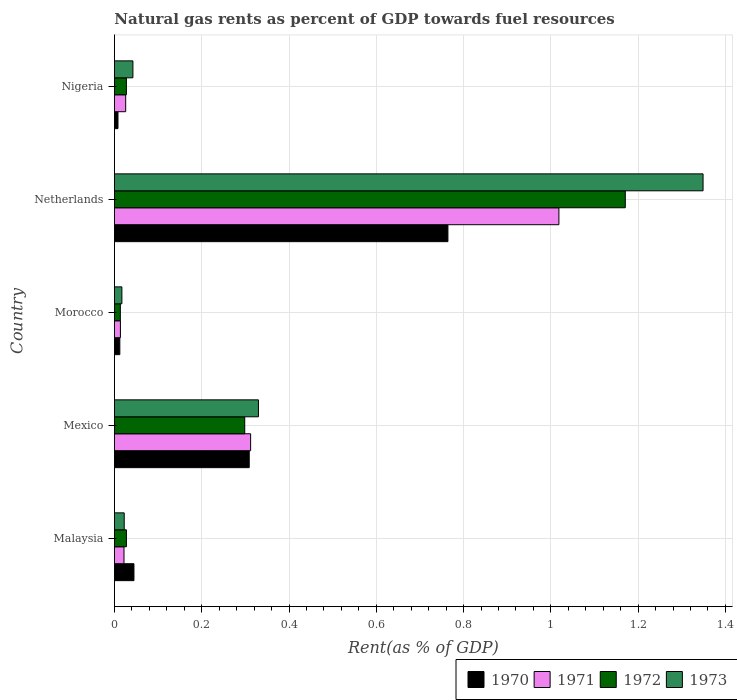How many different coloured bars are there?
Your answer should be very brief. 4. How many groups of bars are there?
Give a very brief answer. 5. Are the number of bars per tick equal to the number of legend labels?
Keep it short and to the point. Yes. Are the number of bars on each tick of the Y-axis equal?
Ensure brevity in your answer.  Yes. What is the matural gas rent in 1971 in Mexico?
Offer a very short reply. 0.31. Across all countries, what is the maximum matural gas rent in 1971?
Make the answer very short. 1.02. Across all countries, what is the minimum matural gas rent in 1972?
Offer a terse response. 0.01. In which country was the matural gas rent in 1973 maximum?
Keep it short and to the point. Netherlands. In which country was the matural gas rent in 1973 minimum?
Your answer should be very brief. Morocco. What is the total matural gas rent in 1970 in the graph?
Ensure brevity in your answer.  1.14. What is the difference between the matural gas rent in 1970 in Malaysia and that in Netherlands?
Keep it short and to the point. -0.72. What is the difference between the matural gas rent in 1970 in Nigeria and the matural gas rent in 1973 in Mexico?
Provide a succinct answer. -0.32. What is the average matural gas rent in 1972 per country?
Your response must be concise. 0.31. What is the difference between the matural gas rent in 1973 and matural gas rent in 1970 in Malaysia?
Offer a very short reply. -0.02. What is the ratio of the matural gas rent in 1973 in Morocco to that in Netherlands?
Make the answer very short. 0.01. What is the difference between the highest and the second highest matural gas rent in 1973?
Give a very brief answer. 1.02. What is the difference between the highest and the lowest matural gas rent in 1971?
Provide a succinct answer. 1. Is it the case that in every country, the sum of the matural gas rent in 1971 and matural gas rent in 1972 is greater than the sum of matural gas rent in 1973 and matural gas rent in 1970?
Offer a terse response. No. What does the 2nd bar from the top in Morocco represents?
Provide a succinct answer. 1972. How many bars are there?
Provide a short and direct response. 20. How many legend labels are there?
Provide a succinct answer. 4. What is the title of the graph?
Offer a very short reply. Natural gas rents as percent of GDP towards fuel resources. What is the label or title of the X-axis?
Provide a short and direct response. Rent(as % of GDP). What is the Rent(as % of GDP) of 1970 in Malaysia?
Your response must be concise. 0.04. What is the Rent(as % of GDP) in 1971 in Malaysia?
Offer a very short reply. 0.02. What is the Rent(as % of GDP) in 1972 in Malaysia?
Offer a very short reply. 0.03. What is the Rent(as % of GDP) in 1973 in Malaysia?
Your answer should be very brief. 0.02. What is the Rent(as % of GDP) of 1970 in Mexico?
Offer a terse response. 0.31. What is the Rent(as % of GDP) in 1971 in Mexico?
Keep it short and to the point. 0.31. What is the Rent(as % of GDP) in 1972 in Mexico?
Give a very brief answer. 0.3. What is the Rent(as % of GDP) in 1973 in Mexico?
Your answer should be compact. 0.33. What is the Rent(as % of GDP) in 1970 in Morocco?
Offer a terse response. 0.01. What is the Rent(as % of GDP) in 1971 in Morocco?
Provide a short and direct response. 0.01. What is the Rent(as % of GDP) in 1972 in Morocco?
Make the answer very short. 0.01. What is the Rent(as % of GDP) in 1973 in Morocco?
Give a very brief answer. 0.02. What is the Rent(as % of GDP) of 1970 in Netherlands?
Ensure brevity in your answer.  0.76. What is the Rent(as % of GDP) in 1971 in Netherlands?
Offer a very short reply. 1.02. What is the Rent(as % of GDP) of 1972 in Netherlands?
Make the answer very short. 1.17. What is the Rent(as % of GDP) in 1973 in Netherlands?
Offer a terse response. 1.35. What is the Rent(as % of GDP) in 1970 in Nigeria?
Your response must be concise. 0.01. What is the Rent(as % of GDP) of 1971 in Nigeria?
Your response must be concise. 0.03. What is the Rent(as % of GDP) of 1972 in Nigeria?
Give a very brief answer. 0.03. What is the Rent(as % of GDP) of 1973 in Nigeria?
Give a very brief answer. 0.04. Across all countries, what is the maximum Rent(as % of GDP) of 1970?
Provide a succinct answer. 0.76. Across all countries, what is the maximum Rent(as % of GDP) of 1971?
Provide a short and direct response. 1.02. Across all countries, what is the maximum Rent(as % of GDP) in 1972?
Your answer should be very brief. 1.17. Across all countries, what is the maximum Rent(as % of GDP) of 1973?
Offer a terse response. 1.35. Across all countries, what is the minimum Rent(as % of GDP) in 1970?
Your response must be concise. 0.01. Across all countries, what is the minimum Rent(as % of GDP) of 1971?
Your answer should be compact. 0.01. Across all countries, what is the minimum Rent(as % of GDP) of 1972?
Your answer should be compact. 0.01. Across all countries, what is the minimum Rent(as % of GDP) of 1973?
Give a very brief answer. 0.02. What is the total Rent(as % of GDP) of 1970 in the graph?
Provide a succinct answer. 1.14. What is the total Rent(as % of GDP) of 1971 in the graph?
Your answer should be very brief. 1.39. What is the total Rent(as % of GDP) of 1972 in the graph?
Give a very brief answer. 1.54. What is the total Rent(as % of GDP) in 1973 in the graph?
Offer a terse response. 1.76. What is the difference between the Rent(as % of GDP) in 1970 in Malaysia and that in Mexico?
Make the answer very short. -0.26. What is the difference between the Rent(as % of GDP) of 1971 in Malaysia and that in Mexico?
Provide a short and direct response. -0.29. What is the difference between the Rent(as % of GDP) in 1972 in Malaysia and that in Mexico?
Your answer should be compact. -0.27. What is the difference between the Rent(as % of GDP) of 1973 in Malaysia and that in Mexico?
Provide a succinct answer. -0.31. What is the difference between the Rent(as % of GDP) of 1970 in Malaysia and that in Morocco?
Your answer should be very brief. 0.03. What is the difference between the Rent(as % of GDP) of 1971 in Malaysia and that in Morocco?
Your answer should be compact. 0.01. What is the difference between the Rent(as % of GDP) of 1972 in Malaysia and that in Morocco?
Your answer should be compact. 0.01. What is the difference between the Rent(as % of GDP) in 1973 in Malaysia and that in Morocco?
Offer a terse response. 0.01. What is the difference between the Rent(as % of GDP) in 1970 in Malaysia and that in Netherlands?
Keep it short and to the point. -0.72. What is the difference between the Rent(as % of GDP) of 1971 in Malaysia and that in Netherlands?
Your answer should be very brief. -1. What is the difference between the Rent(as % of GDP) of 1972 in Malaysia and that in Netherlands?
Give a very brief answer. -1.14. What is the difference between the Rent(as % of GDP) of 1973 in Malaysia and that in Netherlands?
Offer a very short reply. -1.33. What is the difference between the Rent(as % of GDP) of 1970 in Malaysia and that in Nigeria?
Offer a terse response. 0.04. What is the difference between the Rent(as % of GDP) of 1971 in Malaysia and that in Nigeria?
Ensure brevity in your answer.  -0. What is the difference between the Rent(as % of GDP) in 1973 in Malaysia and that in Nigeria?
Provide a succinct answer. -0.02. What is the difference between the Rent(as % of GDP) in 1970 in Mexico and that in Morocco?
Ensure brevity in your answer.  0.3. What is the difference between the Rent(as % of GDP) of 1971 in Mexico and that in Morocco?
Offer a very short reply. 0.3. What is the difference between the Rent(as % of GDP) in 1972 in Mexico and that in Morocco?
Your answer should be compact. 0.28. What is the difference between the Rent(as % of GDP) of 1973 in Mexico and that in Morocco?
Your answer should be very brief. 0.31. What is the difference between the Rent(as % of GDP) in 1970 in Mexico and that in Netherlands?
Offer a very short reply. -0.46. What is the difference between the Rent(as % of GDP) of 1971 in Mexico and that in Netherlands?
Offer a terse response. -0.71. What is the difference between the Rent(as % of GDP) in 1972 in Mexico and that in Netherlands?
Keep it short and to the point. -0.87. What is the difference between the Rent(as % of GDP) in 1973 in Mexico and that in Netherlands?
Give a very brief answer. -1.02. What is the difference between the Rent(as % of GDP) in 1970 in Mexico and that in Nigeria?
Make the answer very short. 0.3. What is the difference between the Rent(as % of GDP) in 1971 in Mexico and that in Nigeria?
Your response must be concise. 0.29. What is the difference between the Rent(as % of GDP) of 1972 in Mexico and that in Nigeria?
Provide a succinct answer. 0.27. What is the difference between the Rent(as % of GDP) in 1973 in Mexico and that in Nigeria?
Your response must be concise. 0.29. What is the difference between the Rent(as % of GDP) in 1970 in Morocco and that in Netherlands?
Your response must be concise. -0.75. What is the difference between the Rent(as % of GDP) in 1971 in Morocco and that in Netherlands?
Ensure brevity in your answer.  -1. What is the difference between the Rent(as % of GDP) of 1972 in Morocco and that in Netherlands?
Provide a succinct answer. -1.16. What is the difference between the Rent(as % of GDP) in 1973 in Morocco and that in Netherlands?
Make the answer very short. -1.33. What is the difference between the Rent(as % of GDP) of 1970 in Morocco and that in Nigeria?
Your response must be concise. 0. What is the difference between the Rent(as % of GDP) in 1971 in Morocco and that in Nigeria?
Make the answer very short. -0.01. What is the difference between the Rent(as % of GDP) in 1972 in Morocco and that in Nigeria?
Provide a short and direct response. -0.01. What is the difference between the Rent(as % of GDP) of 1973 in Morocco and that in Nigeria?
Your response must be concise. -0.03. What is the difference between the Rent(as % of GDP) in 1970 in Netherlands and that in Nigeria?
Keep it short and to the point. 0.76. What is the difference between the Rent(as % of GDP) in 1971 in Netherlands and that in Nigeria?
Ensure brevity in your answer.  0.99. What is the difference between the Rent(as % of GDP) in 1972 in Netherlands and that in Nigeria?
Your answer should be very brief. 1.14. What is the difference between the Rent(as % of GDP) in 1973 in Netherlands and that in Nigeria?
Give a very brief answer. 1.31. What is the difference between the Rent(as % of GDP) in 1970 in Malaysia and the Rent(as % of GDP) in 1971 in Mexico?
Your answer should be very brief. -0.27. What is the difference between the Rent(as % of GDP) of 1970 in Malaysia and the Rent(as % of GDP) of 1972 in Mexico?
Provide a succinct answer. -0.25. What is the difference between the Rent(as % of GDP) of 1970 in Malaysia and the Rent(as % of GDP) of 1973 in Mexico?
Ensure brevity in your answer.  -0.29. What is the difference between the Rent(as % of GDP) of 1971 in Malaysia and the Rent(as % of GDP) of 1972 in Mexico?
Provide a short and direct response. -0.28. What is the difference between the Rent(as % of GDP) in 1971 in Malaysia and the Rent(as % of GDP) in 1973 in Mexico?
Your answer should be very brief. -0.31. What is the difference between the Rent(as % of GDP) of 1972 in Malaysia and the Rent(as % of GDP) of 1973 in Mexico?
Provide a short and direct response. -0.3. What is the difference between the Rent(as % of GDP) of 1970 in Malaysia and the Rent(as % of GDP) of 1971 in Morocco?
Your answer should be very brief. 0.03. What is the difference between the Rent(as % of GDP) in 1970 in Malaysia and the Rent(as % of GDP) in 1972 in Morocco?
Offer a terse response. 0.03. What is the difference between the Rent(as % of GDP) in 1970 in Malaysia and the Rent(as % of GDP) in 1973 in Morocco?
Make the answer very short. 0.03. What is the difference between the Rent(as % of GDP) in 1971 in Malaysia and the Rent(as % of GDP) in 1972 in Morocco?
Your response must be concise. 0.01. What is the difference between the Rent(as % of GDP) of 1971 in Malaysia and the Rent(as % of GDP) of 1973 in Morocco?
Ensure brevity in your answer.  0. What is the difference between the Rent(as % of GDP) of 1972 in Malaysia and the Rent(as % of GDP) of 1973 in Morocco?
Provide a succinct answer. 0.01. What is the difference between the Rent(as % of GDP) in 1970 in Malaysia and the Rent(as % of GDP) in 1971 in Netherlands?
Provide a succinct answer. -0.97. What is the difference between the Rent(as % of GDP) in 1970 in Malaysia and the Rent(as % of GDP) in 1972 in Netherlands?
Provide a succinct answer. -1.13. What is the difference between the Rent(as % of GDP) of 1970 in Malaysia and the Rent(as % of GDP) of 1973 in Netherlands?
Ensure brevity in your answer.  -1.3. What is the difference between the Rent(as % of GDP) of 1971 in Malaysia and the Rent(as % of GDP) of 1972 in Netherlands?
Your response must be concise. -1.15. What is the difference between the Rent(as % of GDP) of 1971 in Malaysia and the Rent(as % of GDP) of 1973 in Netherlands?
Provide a succinct answer. -1.33. What is the difference between the Rent(as % of GDP) of 1972 in Malaysia and the Rent(as % of GDP) of 1973 in Netherlands?
Keep it short and to the point. -1.32. What is the difference between the Rent(as % of GDP) of 1970 in Malaysia and the Rent(as % of GDP) of 1971 in Nigeria?
Offer a terse response. 0.02. What is the difference between the Rent(as % of GDP) of 1970 in Malaysia and the Rent(as % of GDP) of 1972 in Nigeria?
Your answer should be compact. 0.02. What is the difference between the Rent(as % of GDP) of 1970 in Malaysia and the Rent(as % of GDP) of 1973 in Nigeria?
Provide a succinct answer. 0. What is the difference between the Rent(as % of GDP) in 1971 in Malaysia and the Rent(as % of GDP) in 1972 in Nigeria?
Keep it short and to the point. -0.01. What is the difference between the Rent(as % of GDP) of 1971 in Malaysia and the Rent(as % of GDP) of 1973 in Nigeria?
Make the answer very short. -0.02. What is the difference between the Rent(as % of GDP) of 1972 in Malaysia and the Rent(as % of GDP) of 1973 in Nigeria?
Offer a very short reply. -0.01. What is the difference between the Rent(as % of GDP) of 1970 in Mexico and the Rent(as % of GDP) of 1971 in Morocco?
Your answer should be compact. 0.3. What is the difference between the Rent(as % of GDP) in 1970 in Mexico and the Rent(as % of GDP) in 1972 in Morocco?
Provide a succinct answer. 0.3. What is the difference between the Rent(as % of GDP) in 1970 in Mexico and the Rent(as % of GDP) in 1973 in Morocco?
Your answer should be compact. 0.29. What is the difference between the Rent(as % of GDP) of 1971 in Mexico and the Rent(as % of GDP) of 1972 in Morocco?
Make the answer very short. 0.3. What is the difference between the Rent(as % of GDP) in 1971 in Mexico and the Rent(as % of GDP) in 1973 in Morocco?
Provide a succinct answer. 0.29. What is the difference between the Rent(as % of GDP) in 1972 in Mexico and the Rent(as % of GDP) in 1973 in Morocco?
Provide a short and direct response. 0.28. What is the difference between the Rent(as % of GDP) of 1970 in Mexico and the Rent(as % of GDP) of 1971 in Netherlands?
Provide a succinct answer. -0.71. What is the difference between the Rent(as % of GDP) of 1970 in Mexico and the Rent(as % of GDP) of 1972 in Netherlands?
Keep it short and to the point. -0.86. What is the difference between the Rent(as % of GDP) of 1970 in Mexico and the Rent(as % of GDP) of 1973 in Netherlands?
Your response must be concise. -1.04. What is the difference between the Rent(as % of GDP) in 1971 in Mexico and the Rent(as % of GDP) in 1972 in Netherlands?
Offer a very short reply. -0.86. What is the difference between the Rent(as % of GDP) in 1971 in Mexico and the Rent(as % of GDP) in 1973 in Netherlands?
Offer a very short reply. -1.04. What is the difference between the Rent(as % of GDP) in 1972 in Mexico and the Rent(as % of GDP) in 1973 in Netherlands?
Give a very brief answer. -1.05. What is the difference between the Rent(as % of GDP) in 1970 in Mexico and the Rent(as % of GDP) in 1971 in Nigeria?
Offer a very short reply. 0.28. What is the difference between the Rent(as % of GDP) of 1970 in Mexico and the Rent(as % of GDP) of 1972 in Nigeria?
Ensure brevity in your answer.  0.28. What is the difference between the Rent(as % of GDP) of 1970 in Mexico and the Rent(as % of GDP) of 1973 in Nigeria?
Offer a very short reply. 0.27. What is the difference between the Rent(as % of GDP) of 1971 in Mexico and the Rent(as % of GDP) of 1972 in Nigeria?
Give a very brief answer. 0.28. What is the difference between the Rent(as % of GDP) of 1971 in Mexico and the Rent(as % of GDP) of 1973 in Nigeria?
Offer a very short reply. 0.27. What is the difference between the Rent(as % of GDP) of 1972 in Mexico and the Rent(as % of GDP) of 1973 in Nigeria?
Offer a terse response. 0.26. What is the difference between the Rent(as % of GDP) of 1970 in Morocco and the Rent(as % of GDP) of 1971 in Netherlands?
Provide a short and direct response. -1.01. What is the difference between the Rent(as % of GDP) of 1970 in Morocco and the Rent(as % of GDP) of 1972 in Netherlands?
Provide a succinct answer. -1.16. What is the difference between the Rent(as % of GDP) in 1970 in Morocco and the Rent(as % of GDP) in 1973 in Netherlands?
Your answer should be compact. -1.34. What is the difference between the Rent(as % of GDP) of 1971 in Morocco and the Rent(as % of GDP) of 1972 in Netherlands?
Your response must be concise. -1.16. What is the difference between the Rent(as % of GDP) in 1971 in Morocco and the Rent(as % of GDP) in 1973 in Netherlands?
Your answer should be very brief. -1.33. What is the difference between the Rent(as % of GDP) in 1972 in Morocco and the Rent(as % of GDP) in 1973 in Netherlands?
Your answer should be compact. -1.34. What is the difference between the Rent(as % of GDP) in 1970 in Morocco and the Rent(as % of GDP) in 1971 in Nigeria?
Your response must be concise. -0.01. What is the difference between the Rent(as % of GDP) of 1970 in Morocco and the Rent(as % of GDP) of 1972 in Nigeria?
Provide a succinct answer. -0.02. What is the difference between the Rent(as % of GDP) in 1970 in Morocco and the Rent(as % of GDP) in 1973 in Nigeria?
Give a very brief answer. -0.03. What is the difference between the Rent(as % of GDP) in 1971 in Morocco and the Rent(as % of GDP) in 1972 in Nigeria?
Give a very brief answer. -0.01. What is the difference between the Rent(as % of GDP) in 1971 in Morocco and the Rent(as % of GDP) in 1973 in Nigeria?
Your answer should be compact. -0.03. What is the difference between the Rent(as % of GDP) of 1972 in Morocco and the Rent(as % of GDP) of 1973 in Nigeria?
Keep it short and to the point. -0.03. What is the difference between the Rent(as % of GDP) of 1970 in Netherlands and the Rent(as % of GDP) of 1971 in Nigeria?
Give a very brief answer. 0.74. What is the difference between the Rent(as % of GDP) in 1970 in Netherlands and the Rent(as % of GDP) in 1972 in Nigeria?
Your answer should be compact. 0.74. What is the difference between the Rent(as % of GDP) in 1970 in Netherlands and the Rent(as % of GDP) in 1973 in Nigeria?
Give a very brief answer. 0.72. What is the difference between the Rent(as % of GDP) in 1971 in Netherlands and the Rent(as % of GDP) in 1972 in Nigeria?
Provide a short and direct response. 0.99. What is the difference between the Rent(as % of GDP) of 1972 in Netherlands and the Rent(as % of GDP) of 1973 in Nigeria?
Make the answer very short. 1.13. What is the average Rent(as % of GDP) in 1970 per country?
Your answer should be compact. 0.23. What is the average Rent(as % of GDP) of 1971 per country?
Offer a terse response. 0.28. What is the average Rent(as % of GDP) of 1972 per country?
Ensure brevity in your answer.  0.31. What is the average Rent(as % of GDP) of 1973 per country?
Your answer should be very brief. 0.35. What is the difference between the Rent(as % of GDP) of 1970 and Rent(as % of GDP) of 1971 in Malaysia?
Provide a succinct answer. 0.02. What is the difference between the Rent(as % of GDP) of 1970 and Rent(as % of GDP) of 1972 in Malaysia?
Make the answer very short. 0.02. What is the difference between the Rent(as % of GDP) of 1970 and Rent(as % of GDP) of 1973 in Malaysia?
Make the answer very short. 0.02. What is the difference between the Rent(as % of GDP) in 1971 and Rent(as % of GDP) in 1972 in Malaysia?
Your answer should be very brief. -0.01. What is the difference between the Rent(as % of GDP) of 1971 and Rent(as % of GDP) of 1973 in Malaysia?
Offer a very short reply. -0. What is the difference between the Rent(as % of GDP) in 1972 and Rent(as % of GDP) in 1973 in Malaysia?
Provide a succinct answer. 0.01. What is the difference between the Rent(as % of GDP) in 1970 and Rent(as % of GDP) in 1971 in Mexico?
Give a very brief answer. -0. What is the difference between the Rent(as % of GDP) of 1970 and Rent(as % of GDP) of 1972 in Mexico?
Make the answer very short. 0.01. What is the difference between the Rent(as % of GDP) in 1970 and Rent(as % of GDP) in 1973 in Mexico?
Your answer should be very brief. -0.02. What is the difference between the Rent(as % of GDP) in 1971 and Rent(as % of GDP) in 1972 in Mexico?
Your answer should be very brief. 0.01. What is the difference between the Rent(as % of GDP) of 1971 and Rent(as % of GDP) of 1973 in Mexico?
Give a very brief answer. -0.02. What is the difference between the Rent(as % of GDP) in 1972 and Rent(as % of GDP) in 1973 in Mexico?
Your response must be concise. -0.03. What is the difference between the Rent(as % of GDP) of 1970 and Rent(as % of GDP) of 1971 in Morocco?
Provide a short and direct response. -0. What is the difference between the Rent(as % of GDP) in 1970 and Rent(as % of GDP) in 1972 in Morocco?
Provide a short and direct response. -0. What is the difference between the Rent(as % of GDP) of 1970 and Rent(as % of GDP) of 1973 in Morocco?
Offer a very short reply. -0. What is the difference between the Rent(as % of GDP) in 1971 and Rent(as % of GDP) in 1972 in Morocco?
Make the answer very short. 0. What is the difference between the Rent(as % of GDP) of 1971 and Rent(as % of GDP) of 1973 in Morocco?
Offer a very short reply. -0. What is the difference between the Rent(as % of GDP) in 1972 and Rent(as % of GDP) in 1973 in Morocco?
Provide a succinct answer. -0. What is the difference between the Rent(as % of GDP) in 1970 and Rent(as % of GDP) in 1971 in Netherlands?
Provide a succinct answer. -0.25. What is the difference between the Rent(as % of GDP) in 1970 and Rent(as % of GDP) in 1972 in Netherlands?
Provide a short and direct response. -0.41. What is the difference between the Rent(as % of GDP) in 1970 and Rent(as % of GDP) in 1973 in Netherlands?
Keep it short and to the point. -0.58. What is the difference between the Rent(as % of GDP) of 1971 and Rent(as % of GDP) of 1972 in Netherlands?
Your answer should be compact. -0.15. What is the difference between the Rent(as % of GDP) of 1971 and Rent(as % of GDP) of 1973 in Netherlands?
Keep it short and to the point. -0.33. What is the difference between the Rent(as % of GDP) of 1972 and Rent(as % of GDP) of 1973 in Netherlands?
Make the answer very short. -0.18. What is the difference between the Rent(as % of GDP) in 1970 and Rent(as % of GDP) in 1971 in Nigeria?
Make the answer very short. -0.02. What is the difference between the Rent(as % of GDP) of 1970 and Rent(as % of GDP) of 1972 in Nigeria?
Your answer should be very brief. -0.02. What is the difference between the Rent(as % of GDP) in 1970 and Rent(as % of GDP) in 1973 in Nigeria?
Your answer should be very brief. -0.03. What is the difference between the Rent(as % of GDP) in 1971 and Rent(as % of GDP) in 1972 in Nigeria?
Your answer should be very brief. -0. What is the difference between the Rent(as % of GDP) of 1971 and Rent(as % of GDP) of 1973 in Nigeria?
Provide a short and direct response. -0.02. What is the difference between the Rent(as % of GDP) in 1972 and Rent(as % of GDP) in 1973 in Nigeria?
Offer a terse response. -0.01. What is the ratio of the Rent(as % of GDP) of 1970 in Malaysia to that in Mexico?
Offer a terse response. 0.14. What is the ratio of the Rent(as % of GDP) in 1971 in Malaysia to that in Mexico?
Give a very brief answer. 0.07. What is the ratio of the Rent(as % of GDP) of 1972 in Malaysia to that in Mexico?
Your answer should be very brief. 0.09. What is the ratio of the Rent(as % of GDP) of 1973 in Malaysia to that in Mexico?
Ensure brevity in your answer.  0.07. What is the ratio of the Rent(as % of GDP) of 1970 in Malaysia to that in Morocco?
Offer a terse response. 3.62. What is the ratio of the Rent(as % of GDP) of 1971 in Malaysia to that in Morocco?
Your answer should be compact. 1.6. What is the ratio of the Rent(as % of GDP) in 1972 in Malaysia to that in Morocco?
Offer a terse response. 2.03. What is the ratio of the Rent(as % of GDP) of 1973 in Malaysia to that in Morocco?
Make the answer very short. 1.31. What is the ratio of the Rent(as % of GDP) of 1970 in Malaysia to that in Netherlands?
Your response must be concise. 0.06. What is the ratio of the Rent(as % of GDP) in 1971 in Malaysia to that in Netherlands?
Keep it short and to the point. 0.02. What is the ratio of the Rent(as % of GDP) in 1972 in Malaysia to that in Netherlands?
Make the answer very short. 0.02. What is the ratio of the Rent(as % of GDP) in 1973 in Malaysia to that in Netherlands?
Provide a succinct answer. 0.02. What is the ratio of the Rent(as % of GDP) of 1970 in Malaysia to that in Nigeria?
Ensure brevity in your answer.  5.5. What is the ratio of the Rent(as % of GDP) of 1971 in Malaysia to that in Nigeria?
Provide a short and direct response. 0.85. What is the ratio of the Rent(as % of GDP) in 1972 in Malaysia to that in Nigeria?
Provide a succinct answer. 1. What is the ratio of the Rent(as % of GDP) of 1973 in Malaysia to that in Nigeria?
Give a very brief answer. 0.53. What is the ratio of the Rent(as % of GDP) of 1970 in Mexico to that in Morocco?
Keep it short and to the point. 25. What is the ratio of the Rent(as % of GDP) of 1971 in Mexico to that in Morocco?
Offer a very short reply. 22.74. What is the ratio of the Rent(as % of GDP) of 1972 in Mexico to that in Morocco?
Keep it short and to the point. 22.04. What is the ratio of the Rent(as % of GDP) of 1973 in Mexico to that in Morocco?
Provide a short and direct response. 19.3. What is the ratio of the Rent(as % of GDP) of 1970 in Mexico to that in Netherlands?
Offer a very short reply. 0.4. What is the ratio of the Rent(as % of GDP) in 1971 in Mexico to that in Netherlands?
Your answer should be compact. 0.31. What is the ratio of the Rent(as % of GDP) in 1972 in Mexico to that in Netherlands?
Ensure brevity in your answer.  0.26. What is the ratio of the Rent(as % of GDP) in 1973 in Mexico to that in Netherlands?
Your answer should be compact. 0.24. What is the ratio of the Rent(as % of GDP) in 1970 in Mexico to that in Nigeria?
Give a very brief answer. 37.97. What is the ratio of the Rent(as % of GDP) of 1971 in Mexico to that in Nigeria?
Provide a short and direct response. 12.1. What is the ratio of the Rent(as % of GDP) of 1972 in Mexico to that in Nigeria?
Your answer should be very brief. 10.89. What is the ratio of the Rent(as % of GDP) of 1973 in Mexico to that in Nigeria?
Make the answer very short. 7.79. What is the ratio of the Rent(as % of GDP) in 1970 in Morocco to that in Netherlands?
Give a very brief answer. 0.02. What is the ratio of the Rent(as % of GDP) of 1971 in Morocco to that in Netherlands?
Provide a succinct answer. 0.01. What is the ratio of the Rent(as % of GDP) of 1972 in Morocco to that in Netherlands?
Your answer should be compact. 0.01. What is the ratio of the Rent(as % of GDP) in 1973 in Morocco to that in Netherlands?
Offer a very short reply. 0.01. What is the ratio of the Rent(as % of GDP) in 1970 in Morocco to that in Nigeria?
Keep it short and to the point. 1.52. What is the ratio of the Rent(as % of GDP) in 1971 in Morocco to that in Nigeria?
Your response must be concise. 0.53. What is the ratio of the Rent(as % of GDP) of 1972 in Morocco to that in Nigeria?
Offer a very short reply. 0.49. What is the ratio of the Rent(as % of GDP) of 1973 in Morocco to that in Nigeria?
Offer a terse response. 0.4. What is the ratio of the Rent(as % of GDP) in 1970 in Netherlands to that in Nigeria?
Offer a very short reply. 93.94. What is the ratio of the Rent(as % of GDP) of 1971 in Netherlands to that in Nigeria?
Ensure brevity in your answer.  39.48. What is the ratio of the Rent(as % of GDP) of 1972 in Netherlands to that in Nigeria?
Your answer should be compact. 42.7. What is the ratio of the Rent(as % of GDP) in 1973 in Netherlands to that in Nigeria?
Make the answer very short. 31.84. What is the difference between the highest and the second highest Rent(as % of GDP) of 1970?
Give a very brief answer. 0.46. What is the difference between the highest and the second highest Rent(as % of GDP) of 1971?
Make the answer very short. 0.71. What is the difference between the highest and the second highest Rent(as % of GDP) in 1972?
Provide a succinct answer. 0.87. What is the difference between the highest and the second highest Rent(as % of GDP) in 1973?
Offer a very short reply. 1.02. What is the difference between the highest and the lowest Rent(as % of GDP) of 1970?
Your answer should be compact. 0.76. What is the difference between the highest and the lowest Rent(as % of GDP) of 1972?
Make the answer very short. 1.16. What is the difference between the highest and the lowest Rent(as % of GDP) of 1973?
Your response must be concise. 1.33. 